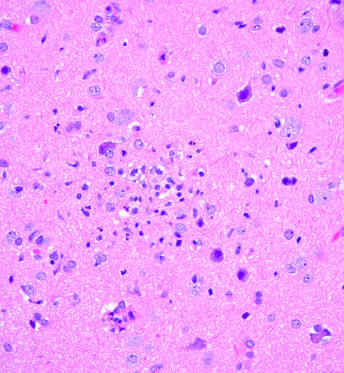did collection of microglial cells form a poorly defined nodule?
Answer the question using a single word or phrase. Yes 